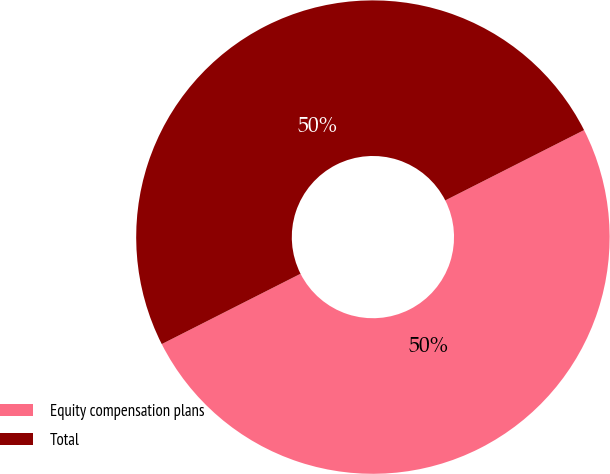Convert chart. <chart><loc_0><loc_0><loc_500><loc_500><pie_chart><fcel>Equity compensation plans<fcel>Total<nl><fcel>50.0%<fcel>50.0%<nl></chart> 